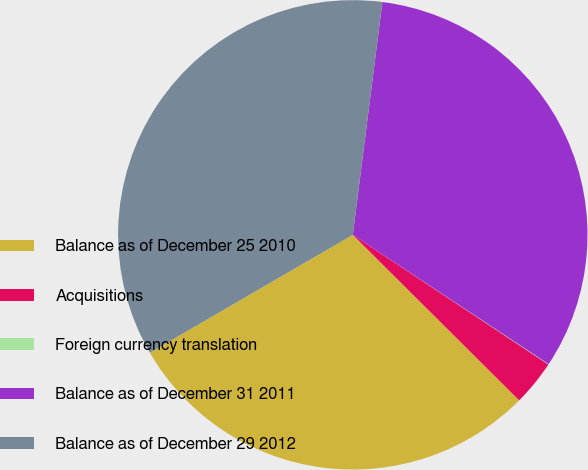Convert chart to OTSL. <chart><loc_0><loc_0><loc_500><loc_500><pie_chart><fcel>Balance as of December 25 2010<fcel>Acquisitions<fcel>Foreign currency translation<fcel>Balance as of December 31 2011<fcel>Balance as of December 29 2012<nl><fcel>29.17%<fcel>3.14%<fcel>0.03%<fcel>32.28%<fcel>35.39%<nl></chart> 